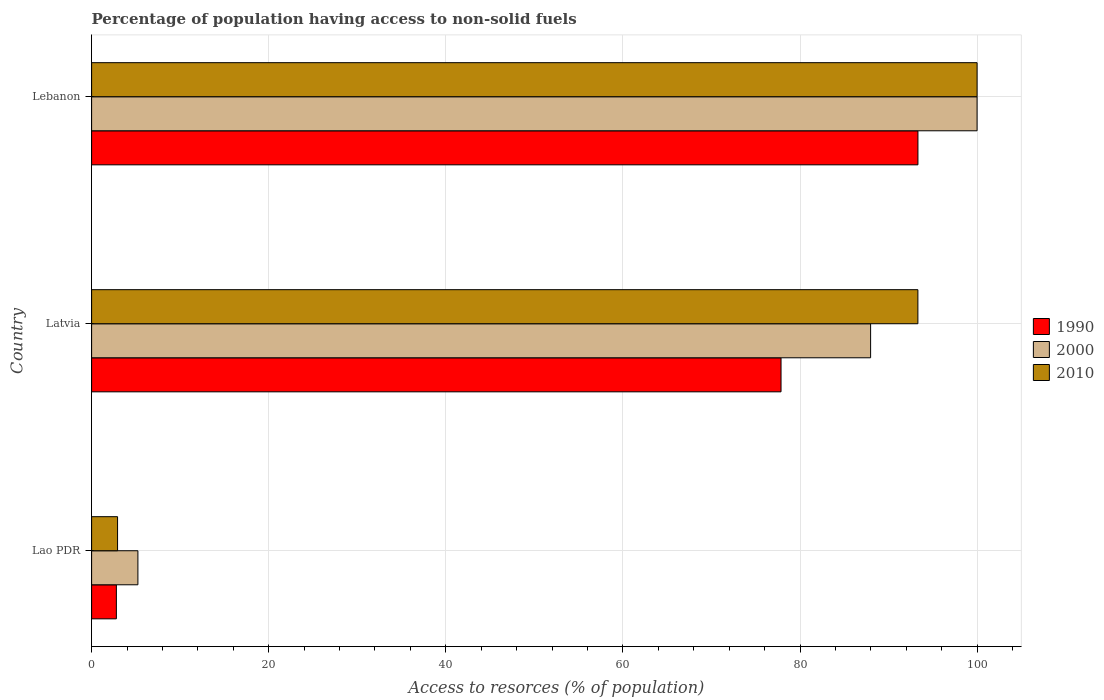Are the number of bars per tick equal to the number of legend labels?
Make the answer very short. Yes. How many bars are there on the 3rd tick from the bottom?
Ensure brevity in your answer.  3. What is the label of the 1st group of bars from the top?
Provide a short and direct response. Lebanon. In how many cases, is the number of bars for a given country not equal to the number of legend labels?
Provide a succinct answer. 0. What is the percentage of population having access to non-solid fuels in 2000 in Lebanon?
Provide a succinct answer. 99.99. Across all countries, what is the maximum percentage of population having access to non-solid fuels in 2000?
Offer a terse response. 99.99. Across all countries, what is the minimum percentage of population having access to non-solid fuels in 1990?
Keep it short and to the point. 2.8. In which country was the percentage of population having access to non-solid fuels in 2010 maximum?
Your answer should be compact. Lebanon. In which country was the percentage of population having access to non-solid fuels in 1990 minimum?
Your answer should be compact. Lao PDR. What is the total percentage of population having access to non-solid fuels in 2010 in the graph?
Keep it short and to the point. 196.23. What is the difference between the percentage of population having access to non-solid fuels in 1990 in Lao PDR and that in Latvia?
Keep it short and to the point. -75.05. What is the difference between the percentage of population having access to non-solid fuels in 2000 in Lao PDR and the percentage of population having access to non-solid fuels in 2010 in Latvia?
Offer a very short reply. -88.08. What is the average percentage of population having access to non-solid fuels in 2010 per country?
Provide a succinct answer. 65.41. What is the difference between the percentage of population having access to non-solid fuels in 1990 and percentage of population having access to non-solid fuels in 2010 in Lebanon?
Offer a very short reply. -6.68. What is the ratio of the percentage of population having access to non-solid fuels in 2010 in Latvia to that in Lebanon?
Provide a short and direct response. 0.93. Is the difference between the percentage of population having access to non-solid fuels in 1990 in Lao PDR and Latvia greater than the difference between the percentage of population having access to non-solid fuels in 2010 in Lao PDR and Latvia?
Offer a terse response. Yes. What is the difference between the highest and the second highest percentage of population having access to non-solid fuels in 2010?
Provide a succinct answer. 6.68. What is the difference between the highest and the lowest percentage of population having access to non-solid fuels in 2000?
Offer a very short reply. 94.76. What does the 1st bar from the top in Lebanon represents?
Your answer should be compact. 2010. What does the 3rd bar from the bottom in Latvia represents?
Ensure brevity in your answer.  2010. Is it the case that in every country, the sum of the percentage of population having access to non-solid fuels in 2000 and percentage of population having access to non-solid fuels in 1990 is greater than the percentage of population having access to non-solid fuels in 2010?
Provide a short and direct response. Yes. How many bars are there?
Ensure brevity in your answer.  9. How many countries are there in the graph?
Keep it short and to the point. 3. Does the graph contain any zero values?
Your answer should be very brief. No. Does the graph contain grids?
Give a very brief answer. Yes. How are the legend labels stacked?
Make the answer very short. Vertical. What is the title of the graph?
Keep it short and to the point. Percentage of population having access to non-solid fuels. What is the label or title of the X-axis?
Your answer should be very brief. Access to resorces (% of population). What is the label or title of the Y-axis?
Give a very brief answer. Country. What is the Access to resorces (% of population) in 1990 in Lao PDR?
Provide a succinct answer. 2.8. What is the Access to resorces (% of population) in 2000 in Lao PDR?
Provide a short and direct response. 5.23. What is the Access to resorces (% of population) of 2010 in Lao PDR?
Provide a succinct answer. 2.93. What is the Access to resorces (% of population) of 1990 in Latvia?
Offer a very short reply. 77.85. What is the Access to resorces (% of population) in 2000 in Latvia?
Your answer should be compact. 87.97. What is the Access to resorces (% of population) of 2010 in Latvia?
Ensure brevity in your answer.  93.31. What is the Access to resorces (% of population) of 1990 in Lebanon?
Your answer should be compact. 93.31. What is the Access to resorces (% of population) in 2000 in Lebanon?
Provide a succinct answer. 99.99. What is the Access to resorces (% of population) in 2010 in Lebanon?
Give a very brief answer. 99.99. Across all countries, what is the maximum Access to resorces (% of population) in 1990?
Provide a succinct answer. 93.31. Across all countries, what is the maximum Access to resorces (% of population) in 2000?
Give a very brief answer. 99.99. Across all countries, what is the maximum Access to resorces (% of population) of 2010?
Your answer should be very brief. 99.99. Across all countries, what is the minimum Access to resorces (% of population) in 1990?
Your answer should be very brief. 2.8. Across all countries, what is the minimum Access to resorces (% of population) of 2000?
Your answer should be compact. 5.23. Across all countries, what is the minimum Access to resorces (% of population) of 2010?
Offer a terse response. 2.93. What is the total Access to resorces (% of population) of 1990 in the graph?
Offer a very short reply. 173.96. What is the total Access to resorces (% of population) in 2000 in the graph?
Give a very brief answer. 193.18. What is the total Access to resorces (% of population) in 2010 in the graph?
Offer a terse response. 196.23. What is the difference between the Access to resorces (% of population) of 1990 in Lao PDR and that in Latvia?
Keep it short and to the point. -75.05. What is the difference between the Access to resorces (% of population) in 2000 in Lao PDR and that in Latvia?
Your response must be concise. -82.74. What is the difference between the Access to resorces (% of population) in 2010 in Lao PDR and that in Latvia?
Make the answer very short. -90.37. What is the difference between the Access to resorces (% of population) of 1990 in Lao PDR and that in Lebanon?
Offer a very short reply. -90.51. What is the difference between the Access to resorces (% of population) of 2000 in Lao PDR and that in Lebanon?
Provide a succinct answer. -94.76. What is the difference between the Access to resorces (% of population) in 2010 in Lao PDR and that in Lebanon?
Ensure brevity in your answer.  -97.06. What is the difference between the Access to resorces (% of population) of 1990 in Latvia and that in Lebanon?
Your response must be concise. -15.46. What is the difference between the Access to resorces (% of population) in 2000 in Latvia and that in Lebanon?
Provide a short and direct response. -12.02. What is the difference between the Access to resorces (% of population) of 2010 in Latvia and that in Lebanon?
Provide a succinct answer. -6.68. What is the difference between the Access to resorces (% of population) in 1990 in Lao PDR and the Access to resorces (% of population) in 2000 in Latvia?
Offer a very short reply. -85.17. What is the difference between the Access to resorces (% of population) in 1990 in Lao PDR and the Access to resorces (% of population) in 2010 in Latvia?
Make the answer very short. -90.51. What is the difference between the Access to resorces (% of population) of 2000 in Lao PDR and the Access to resorces (% of population) of 2010 in Latvia?
Your answer should be very brief. -88.08. What is the difference between the Access to resorces (% of population) of 1990 in Lao PDR and the Access to resorces (% of population) of 2000 in Lebanon?
Your answer should be compact. -97.19. What is the difference between the Access to resorces (% of population) of 1990 in Lao PDR and the Access to resorces (% of population) of 2010 in Lebanon?
Make the answer very short. -97.19. What is the difference between the Access to resorces (% of population) in 2000 in Lao PDR and the Access to resorces (% of population) in 2010 in Lebanon?
Your answer should be very brief. -94.76. What is the difference between the Access to resorces (% of population) of 1990 in Latvia and the Access to resorces (% of population) of 2000 in Lebanon?
Offer a very short reply. -22.14. What is the difference between the Access to resorces (% of population) in 1990 in Latvia and the Access to resorces (% of population) in 2010 in Lebanon?
Give a very brief answer. -22.14. What is the difference between the Access to resorces (% of population) in 2000 in Latvia and the Access to resorces (% of population) in 2010 in Lebanon?
Your answer should be compact. -12.02. What is the average Access to resorces (% of population) of 1990 per country?
Keep it short and to the point. 57.99. What is the average Access to resorces (% of population) of 2000 per country?
Make the answer very short. 64.39. What is the average Access to resorces (% of population) of 2010 per country?
Give a very brief answer. 65.41. What is the difference between the Access to resorces (% of population) of 1990 and Access to resorces (% of population) of 2000 in Lao PDR?
Your answer should be very brief. -2.43. What is the difference between the Access to resorces (% of population) in 1990 and Access to resorces (% of population) in 2010 in Lao PDR?
Ensure brevity in your answer.  -0.14. What is the difference between the Access to resorces (% of population) of 2000 and Access to resorces (% of population) of 2010 in Lao PDR?
Your answer should be compact. 2.3. What is the difference between the Access to resorces (% of population) in 1990 and Access to resorces (% of population) in 2000 in Latvia?
Make the answer very short. -10.12. What is the difference between the Access to resorces (% of population) of 1990 and Access to resorces (% of population) of 2010 in Latvia?
Your answer should be compact. -15.46. What is the difference between the Access to resorces (% of population) in 2000 and Access to resorces (% of population) in 2010 in Latvia?
Provide a short and direct response. -5.34. What is the difference between the Access to resorces (% of population) of 1990 and Access to resorces (% of population) of 2000 in Lebanon?
Ensure brevity in your answer.  -6.68. What is the difference between the Access to resorces (% of population) in 1990 and Access to resorces (% of population) in 2010 in Lebanon?
Make the answer very short. -6.68. What is the difference between the Access to resorces (% of population) of 2000 and Access to resorces (% of population) of 2010 in Lebanon?
Make the answer very short. -0. What is the ratio of the Access to resorces (% of population) in 1990 in Lao PDR to that in Latvia?
Your answer should be very brief. 0.04. What is the ratio of the Access to resorces (% of population) of 2000 in Lao PDR to that in Latvia?
Provide a succinct answer. 0.06. What is the ratio of the Access to resorces (% of population) in 2010 in Lao PDR to that in Latvia?
Provide a succinct answer. 0.03. What is the ratio of the Access to resorces (% of population) in 1990 in Lao PDR to that in Lebanon?
Provide a succinct answer. 0.03. What is the ratio of the Access to resorces (% of population) of 2000 in Lao PDR to that in Lebanon?
Make the answer very short. 0.05. What is the ratio of the Access to resorces (% of population) of 2010 in Lao PDR to that in Lebanon?
Your answer should be very brief. 0.03. What is the ratio of the Access to resorces (% of population) of 1990 in Latvia to that in Lebanon?
Make the answer very short. 0.83. What is the ratio of the Access to resorces (% of population) of 2000 in Latvia to that in Lebanon?
Make the answer very short. 0.88. What is the ratio of the Access to resorces (% of population) in 2010 in Latvia to that in Lebanon?
Give a very brief answer. 0.93. What is the difference between the highest and the second highest Access to resorces (% of population) of 1990?
Keep it short and to the point. 15.46. What is the difference between the highest and the second highest Access to resorces (% of population) in 2000?
Your answer should be very brief. 12.02. What is the difference between the highest and the second highest Access to resorces (% of population) in 2010?
Provide a succinct answer. 6.68. What is the difference between the highest and the lowest Access to resorces (% of population) of 1990?
Your answer should be compact. 90.51. What is the difference between the highest and the lowest Access to resorces (% of population) in 2000?
Offer a very short reply. 94.76. What is the difference between the highest and the lowest Access to resorces (% of population) in 2010?
Ensure brevity in your answer.  97.06. 